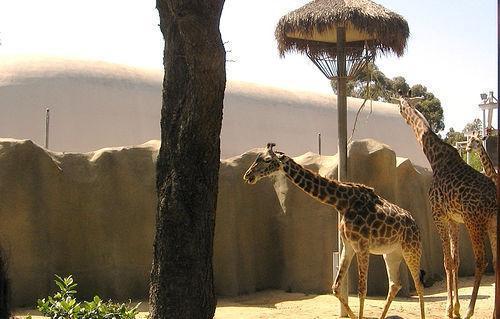How many giraffes are there?
Give a very brief answer. 3. How many giraffe are walking by the wall?
Give a very brief answer. 3. How many people are standing?
Give a very brief answer. 0. 